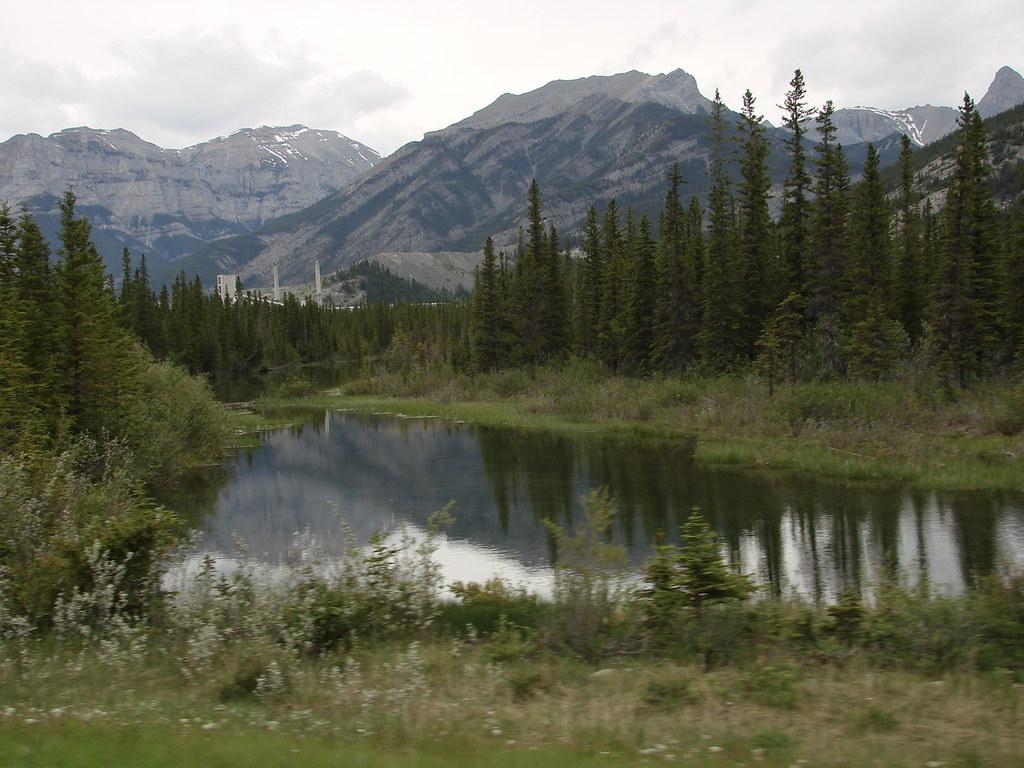What is the main feature in the foreground of the picture? There is a small pond in the picture. What type of vegetation can be seen in the picture? There are plants and trees in the picture. What can be seen in the background of the picture? There are mountains and clouds in the sky in the background of the picture. What type of hammer is being used to create the mountains in the picture? There is no hammer present in the picture, and the mountains are not being created; they are a natural part of the landscape. 